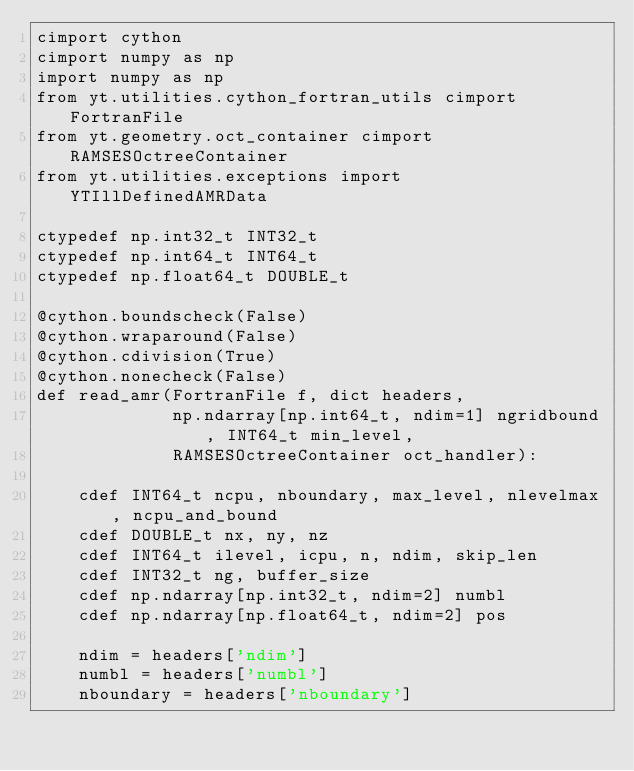Convert code to text. <code><loc_0><loc_0><loc_500><loc_500><_Cython_>cimport cython
cimport numpy as np
import numpy as np
from yt.utilities.cython_fortran_utils cimport FortranFile
from yt.geometry.oct_container cimport RAMSESOctreeContainer
from yt.utilities.exceptions import YTIllDefinedAMRData

ctypedef np.int32_t INT32_t
ctypedef np.int64_t INT64_t
ctypedef np.float64_t DOUBLE_t

@cython.boundscheck(False)
@cython.wraparound(False)
@cython.cdivision(True)
@cython.nonecheck(False)
def read_amr(FortranFile f, dict headers,
             np.ndarray[np.int64_t, ndim=1] ngridbound, INT64_t min_level,
             RAMSESOctreeContainer oct_handler):

    cdef INT64_t ncpu, nboundary, max_level, nlevelmax, ncpu_and_bound
    cdef DOUBLE_t nx, ny, nz
    cdef INT64_t ilevel, icpu, n, ndim, skip_len
    cdef INT32_t ng, buffer_size
    cdef np.ndarray[np.int32_t, ndim=2] numbl
    cdef np.ndarray[np.float64_t, ndim=2] pos

    ndim = headers['ndim']
    numbl = headers['numbl']
    nboundary = headers['nboundary']</code> 